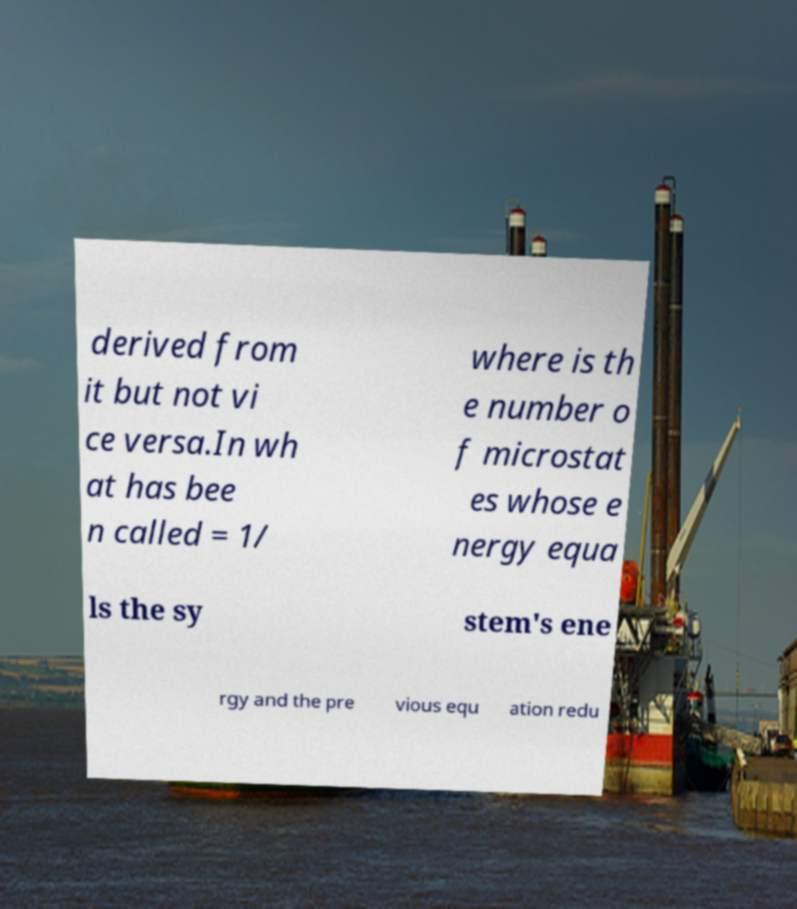Could you assist in decoding the text presented in this image and type it out clearly? derived from it but not vi ce versa.In wh at has bee n called = 1/ where is th e number o f microstat es whose e nergy equa ls the sy stem's ene rgy and the pre vious equ ation redu 